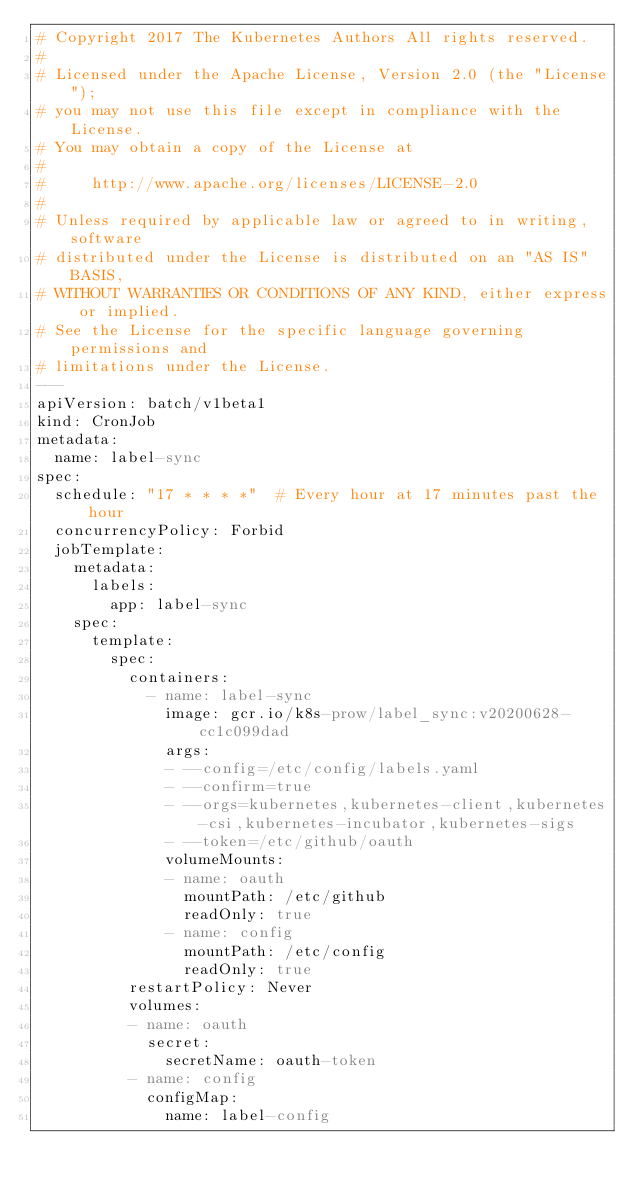<code> <loc_0><loc_0><loc_500><loc_500><_YAML_># Copyright 2017 The Kubernetes Authors All rights reserved.
#
# Licensed under the Apache License, Version 2.0 (the "License");
# you may not use this file except in compliance with the License.
# You may obtain a copy of the License at
#
#     http://www.apache.org/licenses/LICENSE-2.0
#
# Unless required by applicable law or agreed to in writing, software
# distributed under the License is distributed on an "AS IS" BASIS,
# WITHOUT WARRANTIES OR CONDITIONS OF ANY KIND, either express or implied.
# See the License for the specific language governing permissions and
# limitations under the License.
---
apiVersion: batch/v1beta1
kind: CronJob
metadata:
  name: label-sync
spec:
  schedule: "17 * * * *"  # Every hour at 17 minutes past the hour
  concurrencyPolicy: Forbid
  jobTemplate:
    metadata:
      labels:
        app: label-sync
    spec:
      template:
        spec:
          containers:
            - name: label-sync
              image: gcr.io/k8s-prow/label_sync:v20200628-cc1c099dad
              args:
              - --config=/etc/config/labels.yaml
              - --confirm=true
              - --orgs=kubernetes,kubernetes-client,kubernetes-csi,kubernetes-incubator,kubernetes-sigs
              - --token=/etc/github/oauth
              volumeMounts:
              - name: oauth
                mountPath: /etc/github
                readOnly: true
              - name: config
                mountPath: /etc/config
                readOnly: true
          restartPolicy: Never
          volumes:
          - name: oauth
            secret:
              secretName: oauth-token
          - name: config
            configMap:
              name: label-config
</code> 